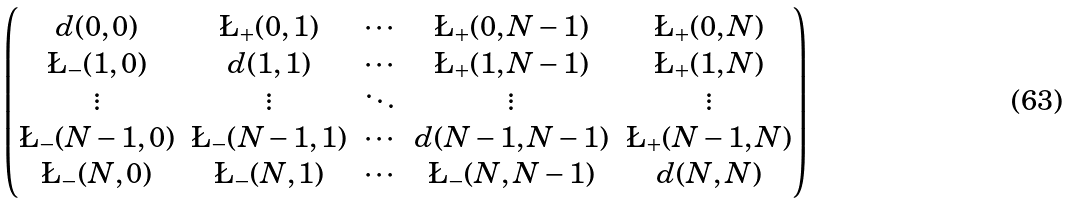<formula> <loc_0><loc_0><loc_500><loc_500>\begin{pmatrix} d ( 0 , 0 ) & \L _ { + } ( 0 , 1 ) & \cdots & \L _ { + } ( 0 , N - 1 ) & \L _ { + } ( 0 , N ) \\ \L _ { - } ( 1 , 0 ) & d ( 1 , 1 ) & \cdots & \L _ { + } ( 1 , N - 1 ) & \L _ { + } ( 1 , N ) \\ \vdots & \vdots & \ddots & \vdots & \vdots \\ \L _ { - } ( N - 1 , 0 ) & \L _ { - } ( N - 1 , 1 ) & \cdots & d ( N - 1 , N - 1 ) & \L _ { + } ( N - 1 , N ) \\ \L _ { - } ( N , 0 ) & \L _ { - } ( N , 1 ) & \cdots & \L _ { - } ( N , N - 1 ) & d ( N , N ) \end{pmatrix}</formula> 